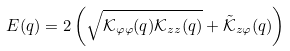Convert formula to latex. <formula><loc_0><loc_0><loc_500><loc_500>E ( q ) = 2 \left ( \sqrt { \mathcal { K } _ { \varphi \varphi } ( q ) \mathcal { K } _ { z z } ( q ) } + \tilde { \mathcal { K } } _ { z \varphi } ( q ) \right )</formula> 